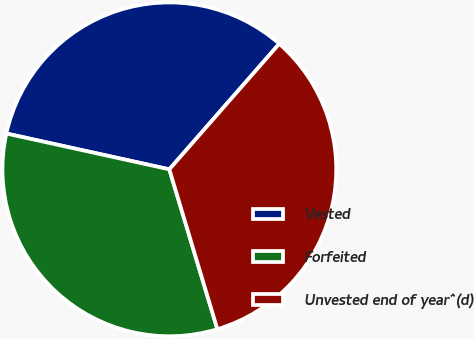Convert chart to OTSL. <chart><loc_0><loc_0><loc_500><loc_500><pie_chart><fcel>Vested<fcel>Forfeited<fcel>Unvested end of year^(d)<nl><fcel>33.0%<fcel>33.09%<fcel>33.91%<nl></chart> 